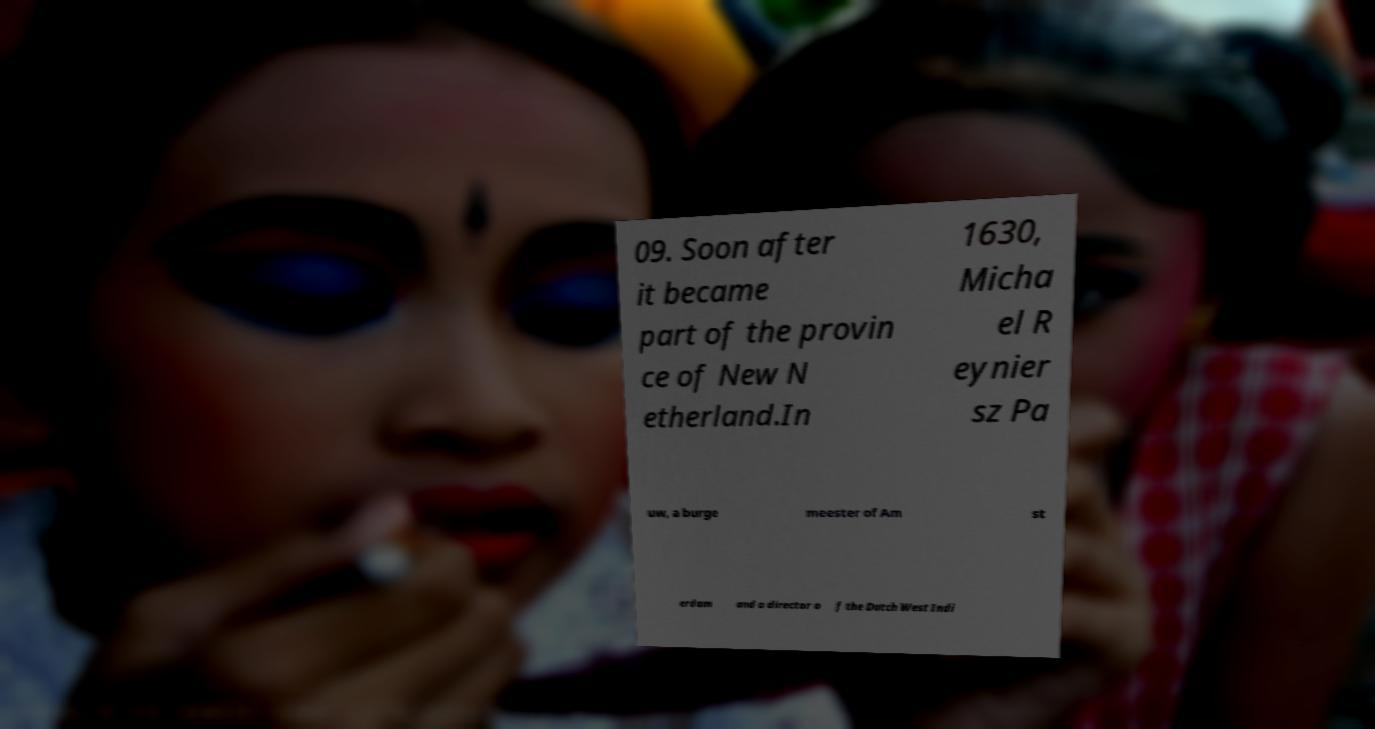What messages or text are displayed in this image? I need them in a readable, typed format. 09. Soon after it became part of the provin ce of New N etherland.In 1630, Micha el R eynier sz Pa uw, a burge meester of Am st erdam and a director o f the Dutch West Indi 